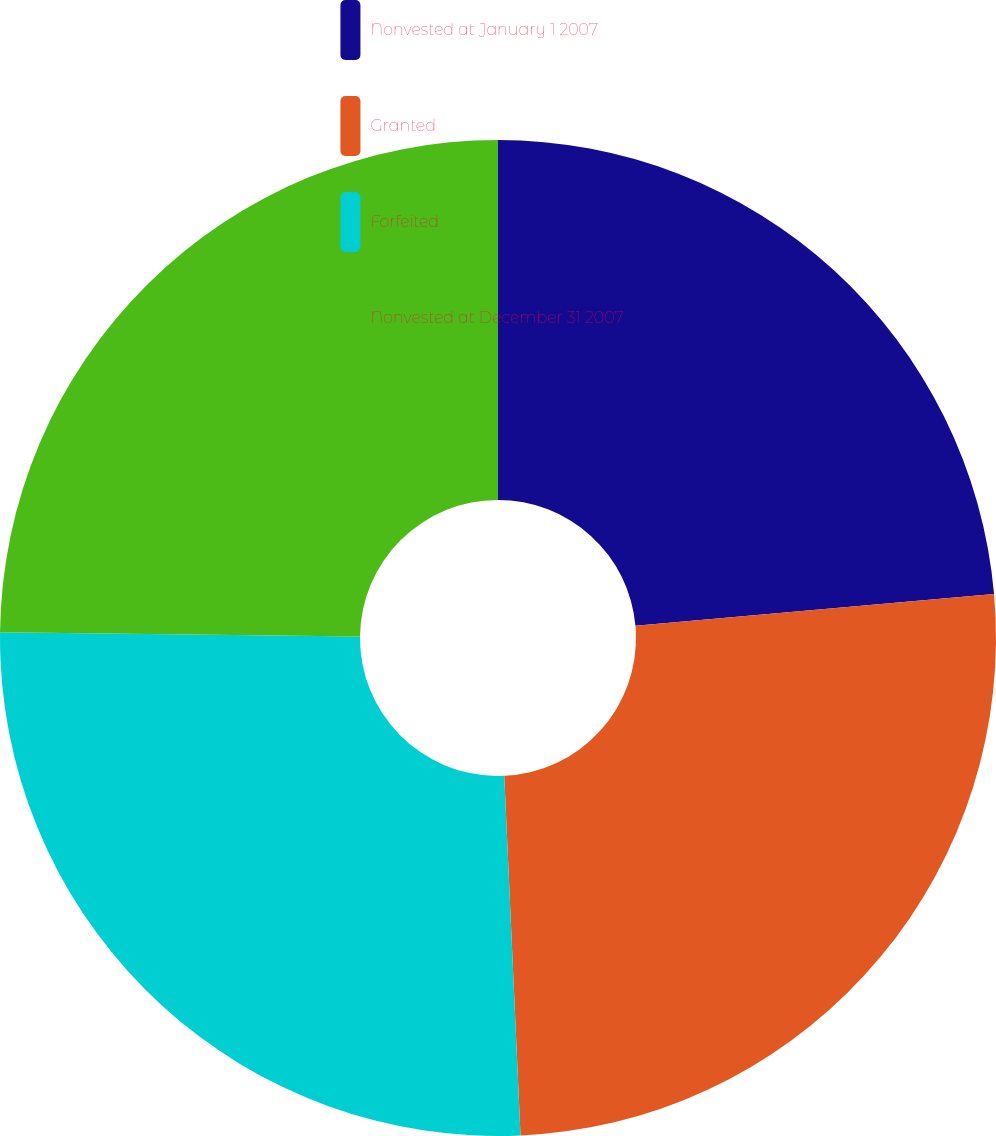Convert chart. <chart><loc_0><loc_0><loc_500><loc_500><pie_chart><fcel>Nonvested at January 1 2007<fcel>Granted<fcel>Forfeited<fcel>Nonvested at December 31 2007<nl><fcel>23.59%<fcel>25.69%<fcel>25.9%<fcel>24.82%<nl></chart> 